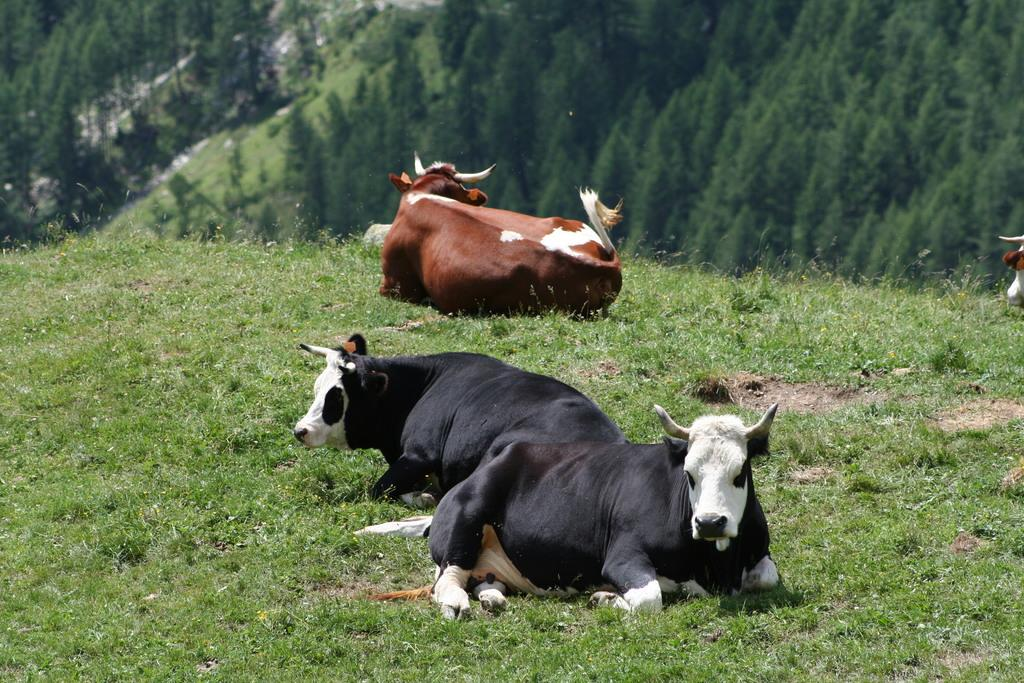How many bulls are present in the image? There are three bulls in the image. What are the bulls doing in the image? The bulls are sitting on the grassland. What can be seen in the background of the image? There are trees visible on a hill in the background of the image. Where is the desk located in the image? There is no desk present in the image. What type of ball can be seen being used by the bulls in the image? There are no balls present in the image; the bulls are sitting on the grassland. 